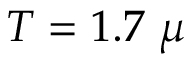Convert formula to latex. <formula><loc_0><loc_0><loc_500><loc_500>T = 1 . 7 \mu</formula> 